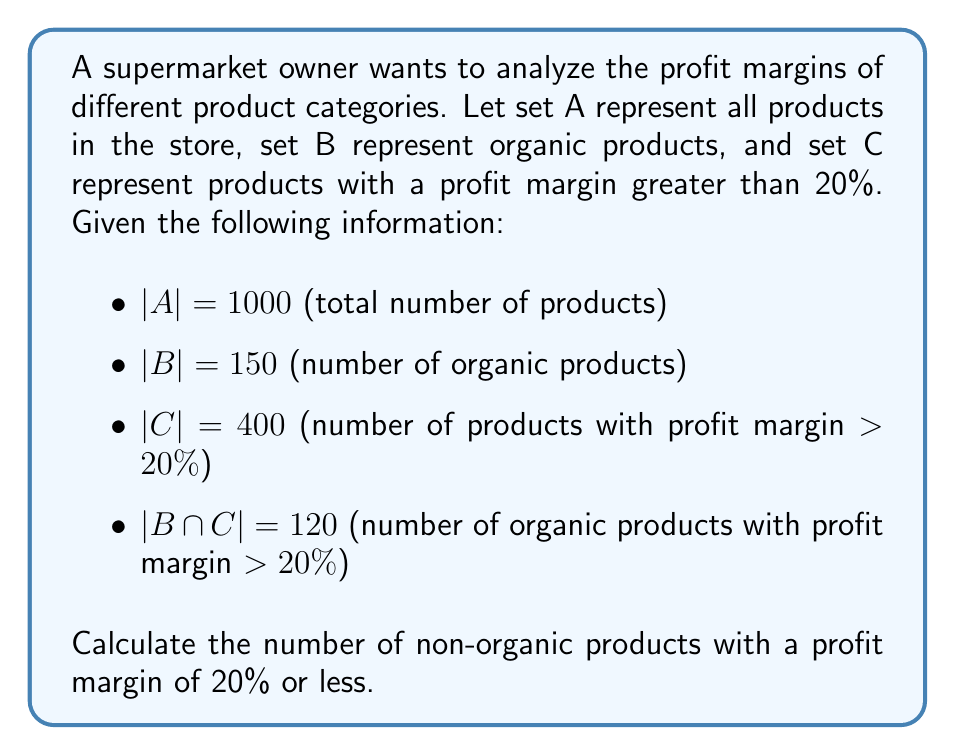Solve this math problem. To solve this problem, we can use set theory principles and the given information. Let's approach this step-by-step:

1) First, we need to find the number of non-organic products with a profit margin > 20%. This is the set $(C - B)$, which can be calculated as:

   $|C - B| = |C| - |B \cap C| = 400 - 120 = 280$

2) Now, we can find the total number of products with a profit margin > 20% (both organic and non-organic):

   $|C| = 400$

3) The number of products with a profit margin ≤ 20% is the complement of C in A:

   $|A - C| = |A| - |C| = 1000 - 400 = 600$

4) To find the number of non-organic products, we subtract the organic products from the total:

   $|A - B| = |A| - |B| = 1000 - 150 = 850$

5) Finally, to find the number of non-organic products with a profit margin ≤ 20%, we subtract the non-organic products with profit margin > 20% from the total non-organic products:

   $|(A - B) - C| = |A - B| - |C - B| = 850 - 280 = 570$

Therefore, there are 570 non-organic products with a profit margin of 20% or less.
Answer: 570 non-organic products have a profit margin of 20% or less. 